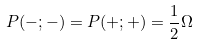Convert formula to latex. <formula><loc_0><loc_0><loc_500><loc_500>P ( - ; - ) = P ( + ; + ) = \frac { 1 } { 2 } \Omega</formula> 